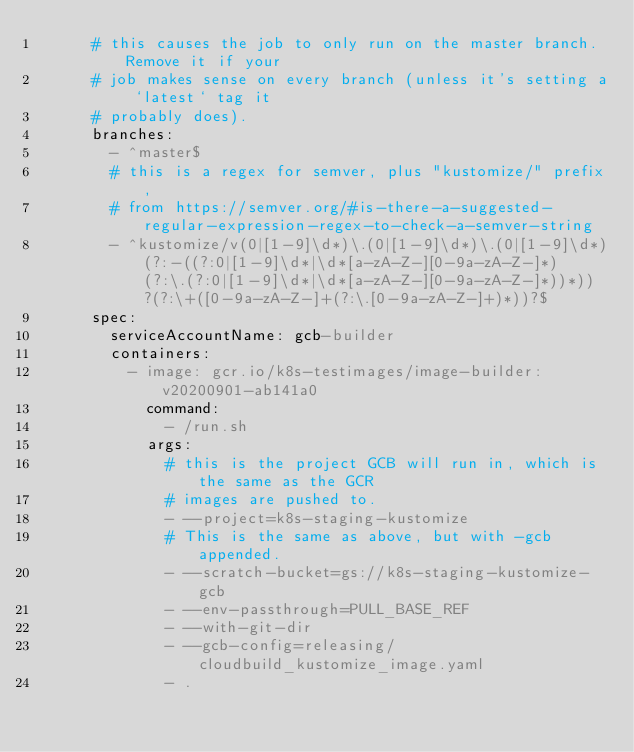Convert code to text. <code><loc_0><loc_0><loc_500><loc_500><_YAML_>      # this causes the job to only run on the master branch. Remove it if your
      # job makes sense on every branch (unless it's setting a `latest` tag it
      # probably does).
      branches:
        - ^master$
        # this is a regex for semver, plus "kustomize/" prefix,
        # from https://semver.org/#is-there-a-suggested-regular-expression-regex-to-check-a-semver-string
        - ^kustomize/v(0|[1-9]\d*)\.(0|[1-9]\d*)\.(0|[1-9]\d*)(?:-((?:0|[1-9]\d*|\d*[a-zA-Z-][0-9a-zA-Z-]*)(?:\.(?:0|[1-9]\d*|\d*[a-zA-Z-][0-9a-zA-Z-]*))*))?(?:\+([0-9a-zA-Z-]+(?:\.[0-9a-zA-Z-]+)*))?$
      spec:
        serviceAccountName: gcb-builder
        containers:
          - image: gcr.io/k8s-testimages/image-builder:v20200901-ab141a0
            command:
              - /run.sh
            args:
              # this is the project GCB will run in, which is the same as the GCR
              # images are pushed to.
              - --project=k8s-staging-kustomize
              # This is the same as above, but with -gcb appended.
              - --scratch-bucket=gs://k8s-staging-kustomize-gcb
              - --env-passthrough=PULL_BASE_REF
              - --with-git-dir
              - --gcb-config=releasing/cloudbuild_kustomize_image.yaml
              - .
</code> 